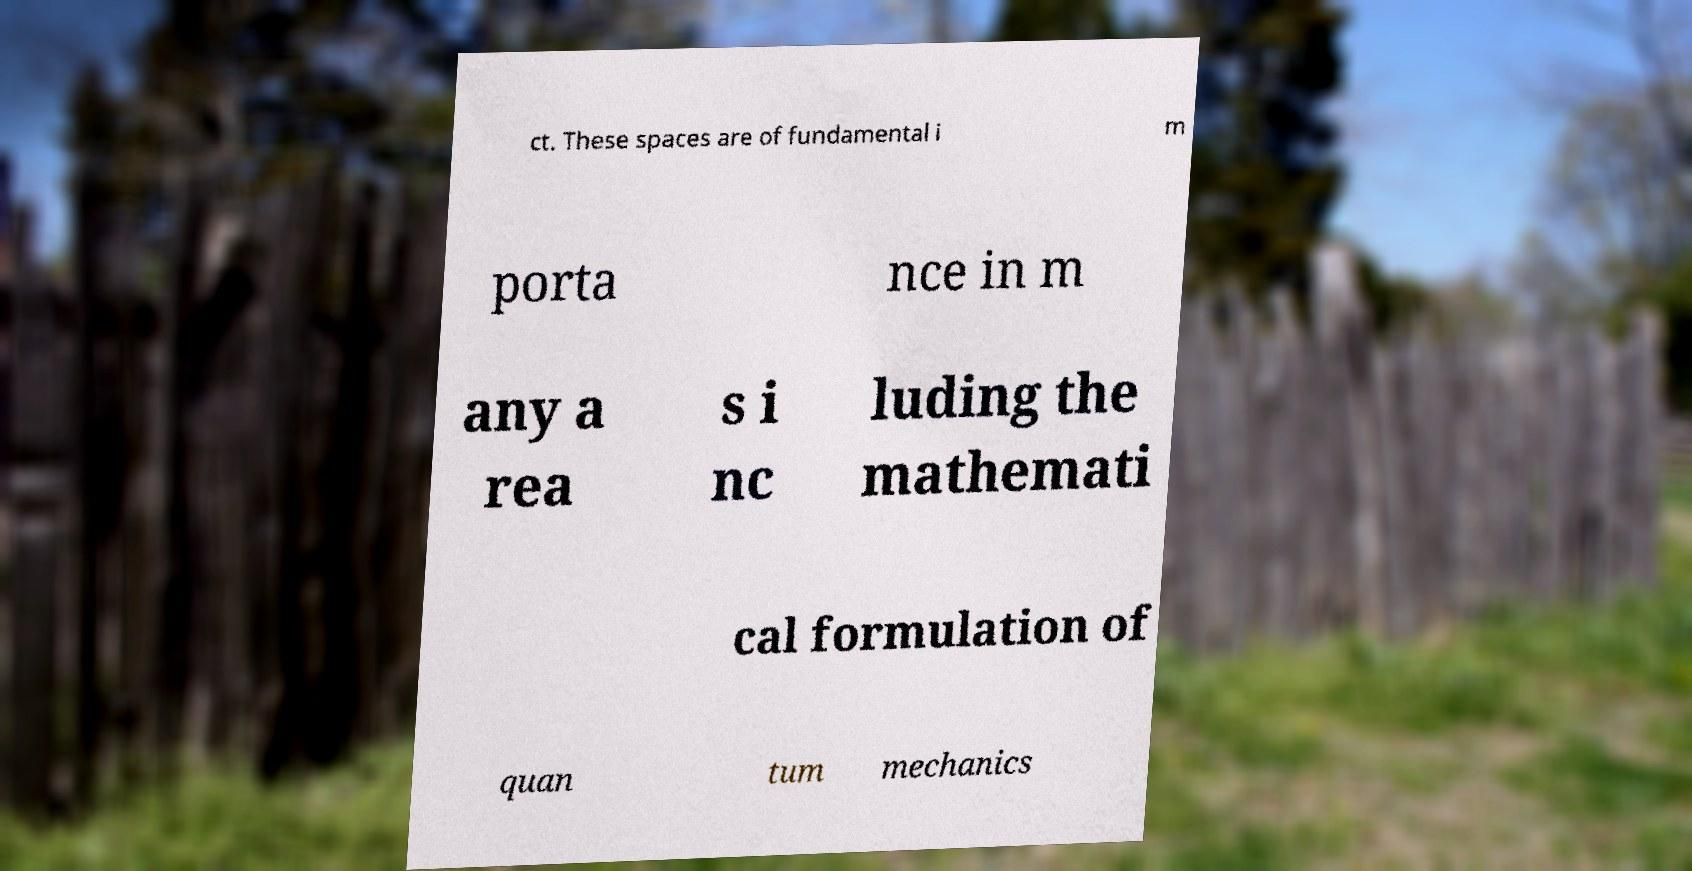Please identify and transcribe the text found in this image. ct. These spaces are of fundamental i m porta nce in m any a rea s i nc luding the mathemati cal formulation of quan tum mechanics 